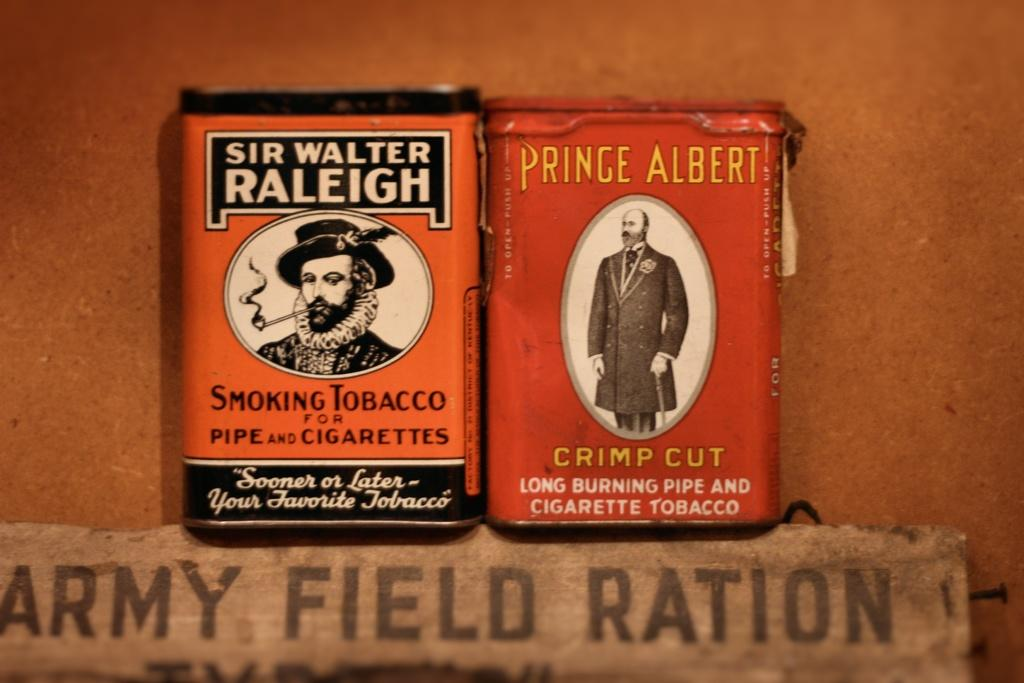<image>
Create a compact narrative representing the image presented. Two packages of tobacco including one called Prince Albert. 